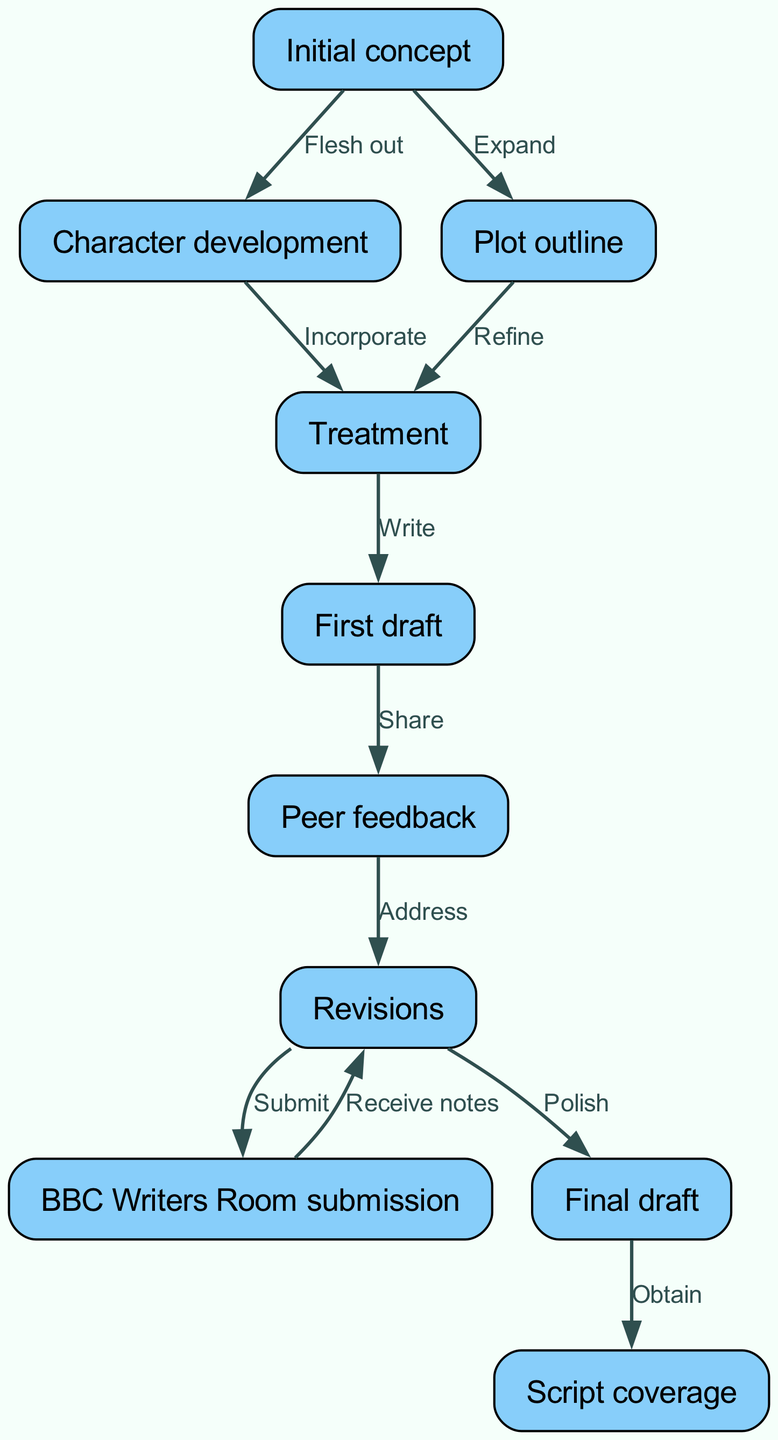What's the first step in the writing process? The first step listed in the diagram is "Initial concept," which starts the flow of the writing process.
Answer: Initial concept How many nodes are in the diagram? By counting all the unique elements representing specific stages in the screenplay process, we can see there are ten nodes: Initial concept, Character development, Plot outline, Treatment, First draft, Peer feedback, BBC Writers Room submission, Revisions, Final draft, and Script coverage.
Answer: 10 What is produced after the "Treatment"? Following the "Treatment" in the flow, the next stage is "First draft," indicating that the first draft is written after completing the treatment stage.
Answer: First draft What relationship exists between "First draft" and "Peer feedback"? The relationship defined by the directed edge shows "Share" as the action taken from "First draft" to "Peer feedback," indicating that the first draft is shared to receive feedback.
Answer: Share How does the process flow from "BBC Writers Room submission" back to "Revisions"? The directed edge from "BBC Writers Room submission" to "Revisions" indicates that after submitting to the BBC Writers Room, the writer receives notes which necessitate revising the draft, essentially creating a loop back to the revisions stage.
Answer: Receive notes Which node directly leads to the final step of "Script coverage"? The node that directly leads to the final step, "Script coverage," is "Final draft," thus indicating that once the final draft is completed, the next step is to obtain script coverage.
Answer: Final draft What does "Plot outline" result in? In the diagram, the "Plot outline" leads to the "Treatment" as indicated by the directed edge labeled "Refine," meaning the plot outline is refined to develop the treatment.
Answer: Treatment What comes before the "Revisions" stage? The stage that comes immediately before "Revisions" is "Peer feedback," which shows that the writer must first gather feedback before making revisions.
Answer: Peer feedback How many edges connect the "Initial concept"? The "Initial concept" is connected by two edges; one leads to "Character development" and the other to "Plot outline," indicating it branches out to these two next stages in the writing process.
Answer: 2 